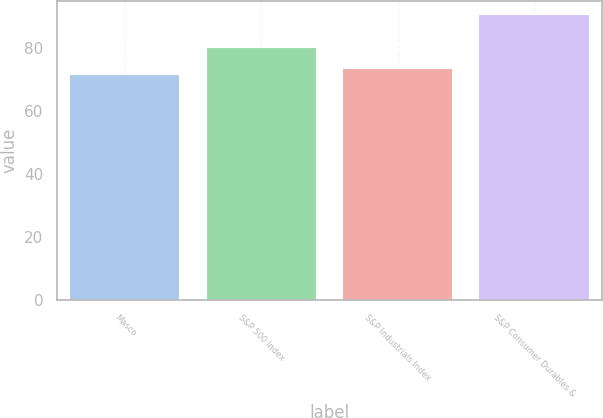Convert chart. <chart><loc_0><loc_0><loc_500><loc_500><bar_chart><fcel>Masco<fcel>S&P 500 Index<fcel>S&P Industrials Index<fcel>S&P Consumer Durables &<nl><fcel>71.52<fcel>79.9<fcel>73.42<fcel>90.54<nl></chart> 